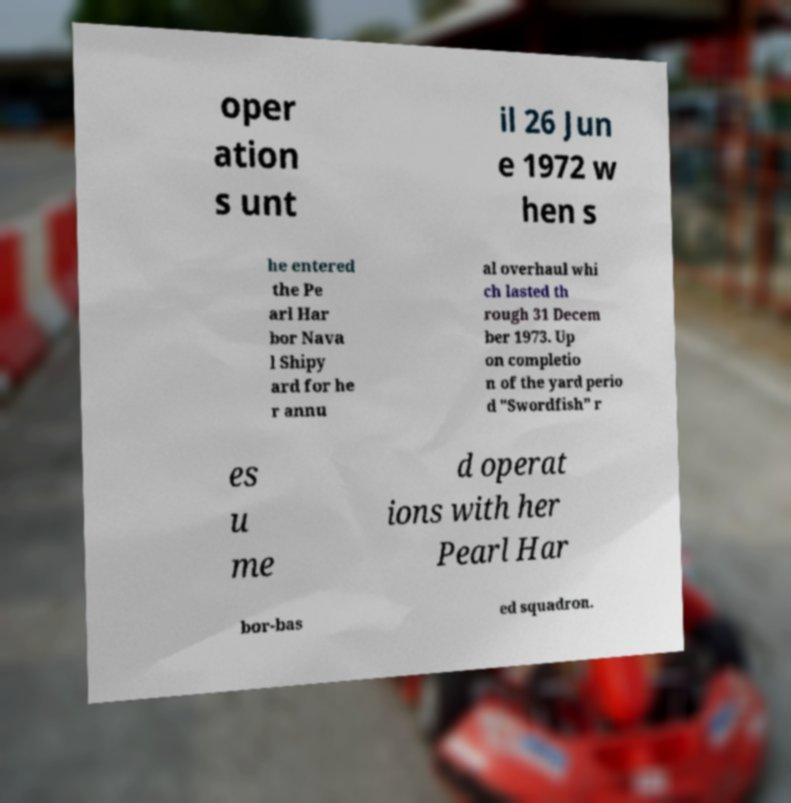Please read and relay the text visible in this image. What does it say? oper ation s unt il 26 Jun e 1972 w hen s he entered the Pe arl Har bor Nava l Shipy ard for he r annu al overhaul whi ch lasted th rough 31 Decem ber 1973. Up on completio n of the yard perio d "Swordfish" r es u me d operat ions with her Pearl Har bor-bas ed squadron. 